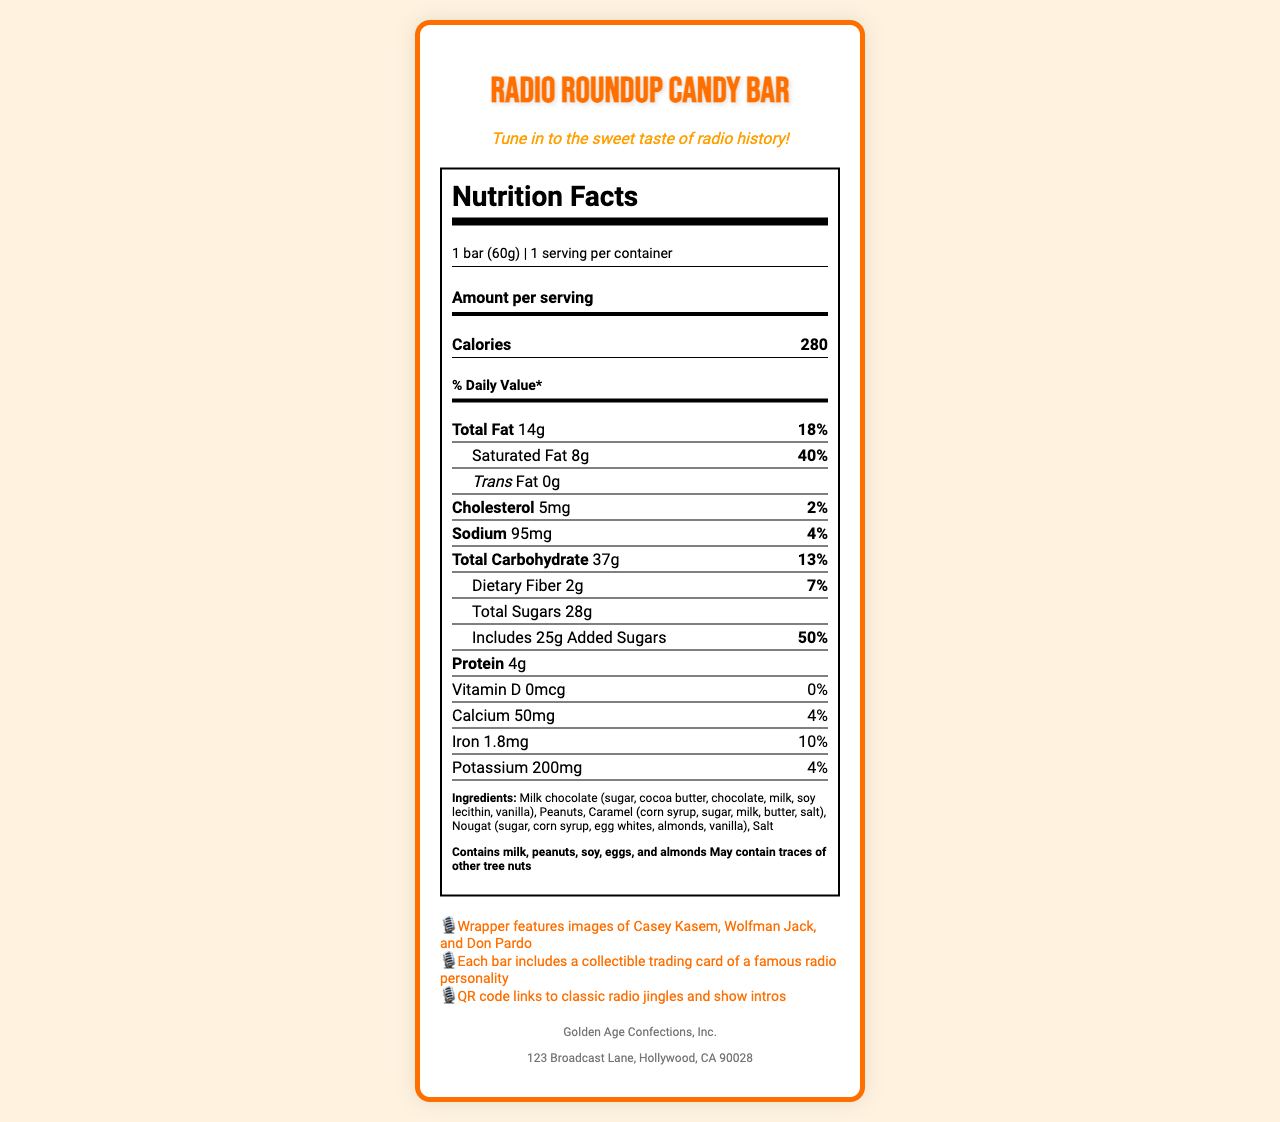what is the serving size for the Radio Roundup Candy Bar? The serving size is listed at the top of the Nutrition Facts section as "1 bar (60g)".
Answer: 1 bar (60g) how many calories are in a single serving of the Radio Roundup Candy Bar? The calories are listed in the Amount per serving section as "280".
Answer: 280 What is the total amount of fat per serving? The total amount of fat is listed as "Total Fat 14g" in the Nutrition Facts.
Answer: 14g how much saturated fat does the candy bar contain? The saturated fat content is listed under Total Fat as "Saturated Fat 8g".
Answer: 8g how many grams of protein are in the candy bar? The protein content is listed in the Nutrition Facts as "Protein 4g".
Answer: 4g what percentage of the daily value of iron is provided by the candy bar? The percent daily value of iron is listed as "10%" next to "Iron 1.8mg".
Answer: 10% what are the main ingredients in the candy bar? The ingredients section lists "Milk chocolate (sugar, cocoa butter, chocolate, milk, soy lecithin, vanilla), Peanuts, Caramel (corn syrup, sugar, milk, butter, salt), Nougat (sugar, corn syrup, egg whites, almonds, vanilla), Salt".
Answer: Milk chocolate, Peanuts, Caramel, Nougat, Salt what allergens does the candy bar contain? The allergens section states "Contains milk, peanuts, soy, eggs, and almonds. May contain traces of other tree nuts".
Answer: Contains milk, peanuts, soy, eggs, and almonds; May contain traces of other tree nuts which of the following is *not* one of the nostalgic elements mentioned on the wrapper? A. Images of Casey Kasem B. Collectible trading card of a famous radio personality C. Trivia questions on famous radio shows D. QR code links to classic radio jingles and show intros The document mentions images of Casey Kasem, a collectible trading card of a famous radio personality, and a QR code link to classic radio jingles and show intros. There is no mention of trivia questions.
Answer: C which daily value percentage is highest on the Nutrition Facts label? A. Total Fat B. Added Sugars C. Saturated Fat D. Cholesterol Added Sugars has the highest daily value percentage at 50%.
Answer: B is there any trans fat in the Radio Roundup Candy Bar? The trans fat content is listed as "0g", which means there is no trans fat in this candy bar.
Answer: No describe the document's main contents, focusing on the Nutrition Facts, ingredients, and nostalgic elements. The document provides an overview of the candy bar's nutritional information, ingredients, allergens, and nostalgic features. It emphasizes the blend of vintage radio-themed packaging and modern candy bar elements.
Answer: The document contains detailed information about the Radio Roundup Candy Bar, including the Nutrition Facts label, which lists serving size, calories, and the amounts of various nutrients such as total fat, saturated fat, cholesterol, sodium, carbohydrates, dietary fiber, sugars, added sugars, protein, vitamins, and minerals. It also includes a list of ingredients, allergen information, and nostalgic elements like images of famous radio personalities, collectible trading cards, and QR codes linking to classic radio jingles. who is the manufacturer of the Radio Roundup Candy Bar? The manufacturer is listed at the bottom of the document as "Golden Age Confections, Inc.".
Answer: Golden Age Confections, Inc. what is the exact address of the manufacturer? The address is given at the bottom of the document as "123 Broadcast Lane, Hollywood, CA 90028".
Answer: 123 Broadcast Lane, Hollywood, CA 90028 how many servings are there per container? The serving information states "1 serving per container."
Answer: 1 how much calcium does the candy bar provide? The document lists the calcium content as "50mg".
Answer: 50mg can you determine the exact percentage of Vitamin D provided by the candy bar? The Vitamin D content is listed in the document as "0mcg", with a daily value of "0%".
Answer: 0% 